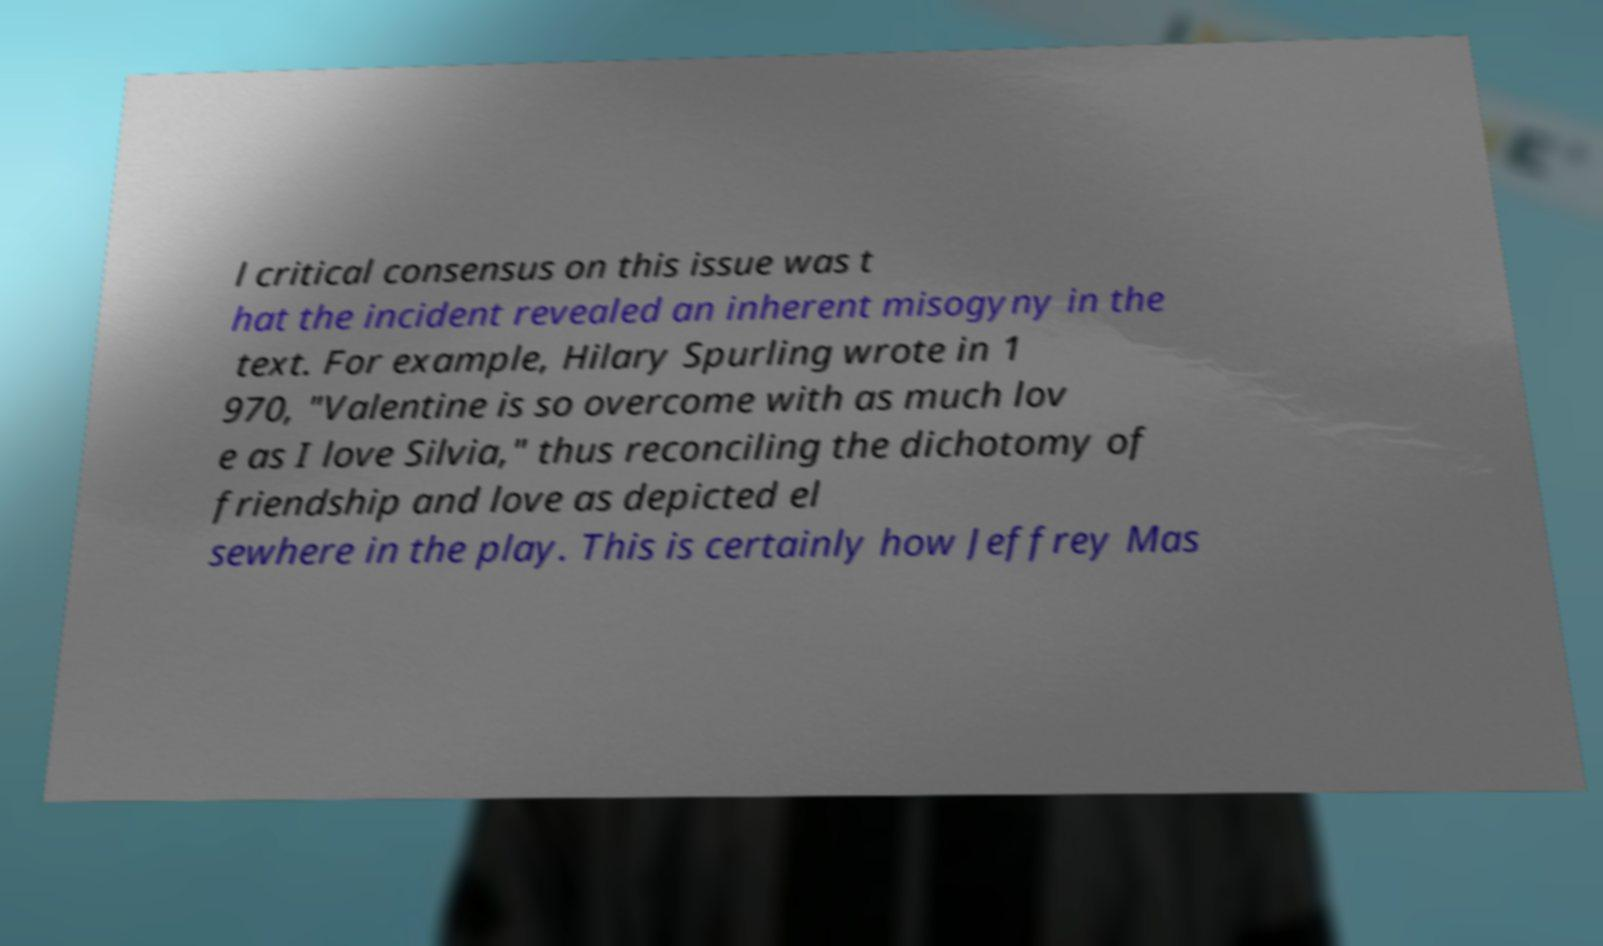Could you assist in decoding the text presented in this image and type it out clearly? l critical consensus on this issue was t hat the incident revealed an inherent misogyny in the text. For example, Hilary Spurling wrote in 1 970, "Valentine is so overcome with as much lov e as I love Silvia," thus reconciling the dichotomy of friendship and love as depicted el sewhere in the play. This is certainly how Jeffrey Mas 